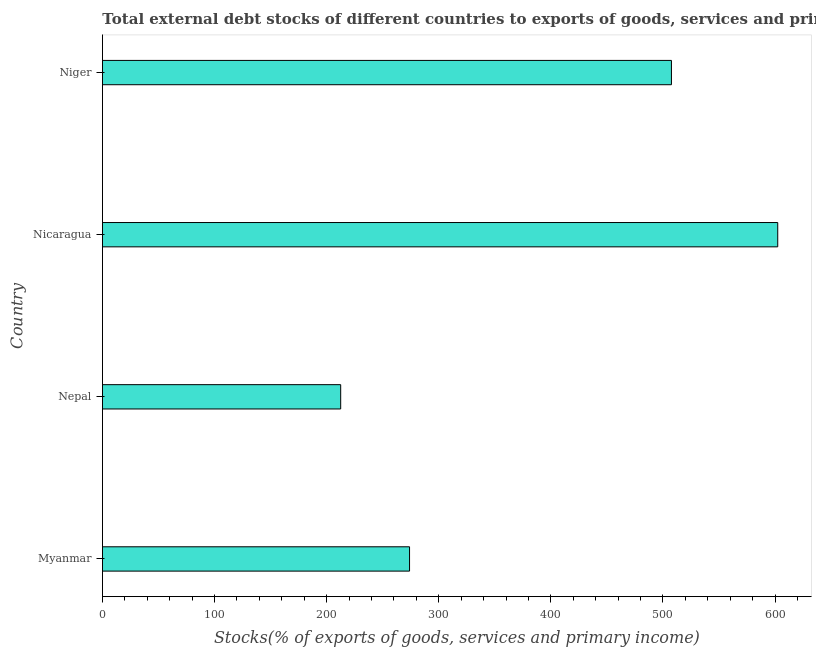Does the graph contain grids?
Your response must be concise. No. What is the title of the graph?
Ensure brevity in your answer.  Total external debt stocks of different countries to exports of goods, services and primary income in 2000. What is the label or title of the X-axis?
Offer a terse response. Stocks(% of exports of goods, services and primary income). What is the label or title of the Y-axis?
Give a very brief answer. Country. What is the external debt stocks in Nicaragua?
Provide a short and direct response. 602.37. Across all countries, what is the maximum external debt stocks?
Keep it short and to the point. 602.37. Across all countries, what is the minimum external debt stocks?
Offer a very short reply. 212.51. In which country was the external debt stocks maximum?
Ensure brevity in your answer.  Nicaragua. In which country was the external debt stocks minimum?
Provide a short and direct response. Nepal. What is the sum of the external debt stocks?
Your answer should be compact. 1596.36. What is the difference between the external debt stocks in Myanmar and Nicaragua?
Ensure brevity in your answer.  -328.44. What is the average external debt stocks per country?
Keep it short and to the point. 399.09. What is the median external debt stocks?
Offer a terse response. 390.74. In how many countries, is the external debt stocks greater than 380 %?
Offer a very short reply. 2. What is the ratio of the external debt stocks in Nepal to that in Niger?
Make the answer very short. 0.42. Is the external debt stocks in Nepal less than that in Niger?
Make the answer very short. Yes. Is the difference between the external debt stocks in Myanmar and Nepal greater than the difference between any two countries?
Your response must be concise. No. What is the difference between the highest and the second highest external debt stocks?
Your response must be concise. 94.81. Is the sum of the external debt stocks in Nepal and Niger greater than the maximum external debt stocks across all countries?
Your answer should be compact. Yes. What is the difference between the highest and the lowest external debt stocks?
Your response must be concise. 389.86. How many bars are there?
Make the answer very short. 4. Are all the bars in the graph horizontal?
Ensure brevity in your answer.  Yes. What is the difference between two consecutive major ticks on the X-axis?
Offer a terse response. 100. Are the values on the major ticks of X-axis written in scientific E-notation?
Offer a very short reply. No. What is the Stocks(% of exports of goods, services and primary income) in Myanmar?
Your response must be concise. 273.93. What is the Stocks(% of exports of goods, services and primary income) of Nepal?
Keep it short and to the point. 212.51. What is the Stocks(% of exports of goods, services and primary income) of Nicaragua?
Provide a short and direct response. 602.37. What is the Stocks(% of exports of goods, services and primary income) in Niger?
Provide a succinct answer. 507.55. What is the difference between the Stocks(% of exports of goods, services and primary income) in Myanmar and Nepal?
Make the answer very short. 61.43. What is the difference between the Stocks(% of exports of goods, services and primary income) in Myanmar and Nicaragua?
Keep it short and to the point. -328.44. What is the difference between the Stocks(% of exports of goods, services and primary income) in Myanmar and Niger?
Offer a very short reply. -233.62. What is the difference between the Stocks(% of exports of goods, services and primary income) in Nepal and Nicaragua?
Ensure brevity in your answer.  -389.86. What is the difference between the Stocks(% of exports of goods, services and primary income) in Nepal and Niger?
Keep it short and to the point. -295.05. What is the difference between the Stocks(% of exports of goods, services and primary income) in Nicaragua and Niger?
Keep it short and to the point. 94.81. What is the ratio of the Stocks(% of exports of goods, services and primary income) in Myanmar to that in Nepal?
Give a very brief answer. 1.29. What is the ratio of the Stocks(% of exports of goods, services and primary income) in Myanmar to that in Nicaragua?
Your answer should be compact. 0.46. What is the ratio of the Stocks(% of exports of goods, services and primary income) in Myanmar to that in Niger?
Give a very brief answer. 0.54. What is the ratio of the Stocks(% of exports of goods, services and primary income) in Nepal to that in Nicaragua?
Offer a very short reply. 0.35. What is the ratio of the Stocks(% of exports of goods, services and primary income) in Nepal to that in Niger?
Make the answer very short. 0.42. What is the ratio of the Stocks(% of exports of goods, services and primary income) in Nicaragua to that in Niger?
Offer a terse response. 1.19. 